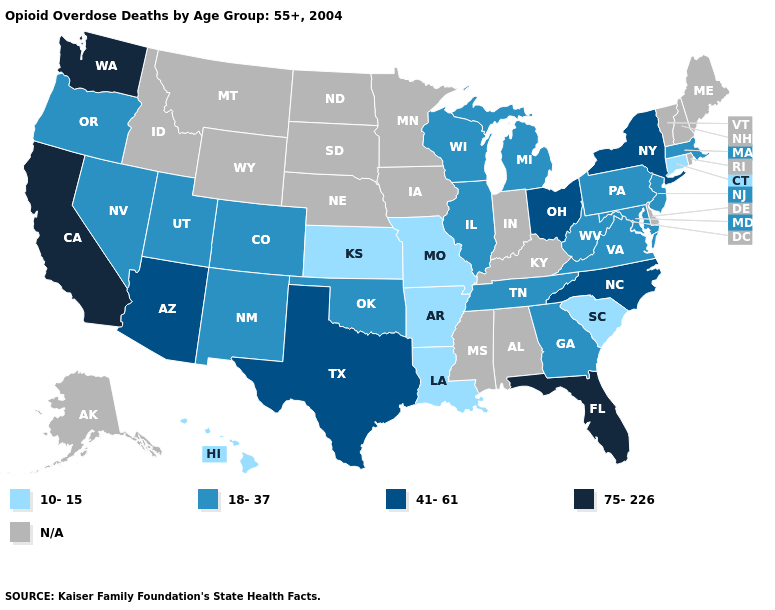What is the lowest value in the Northeast?
Keep it brief. 10-15. What is the value of New Mexico?
Answer briefly. 18-37. Name the states that have a value in the range 41-61?
Concise answer only. Arizona, New York, North Carolina, Ohio, Texas. Does New York have the highest value in the Northeast?
Give a very brief answer. Yes. Name the states that have a value in the range 10-15?
Give a very brief answer. Arkansas, Connecticut, Hawaii, Kansas, Louisiana, Missouri, South Carolina. How many symbols are there in the legend?
Concise answer only. 5. What is the value of South Carolina?
Quick response, please. 10-15. What is the highest value in the South ?
Short answer required. 75-226. Does Washington have the highest value in the USA?
Short answer required. Yes. Among the states that border Rhode Island , which have the highest value?
Be succinct. Massachusetts. What is the value of Louisiana?
Answer briefly. 10-15. Name the states that have a value in the range 75-226?
Short answer required. California, Florida, Washington. What is the value of Idaho?
Keep it brief. N/A. What is the highest value in the South ?
Short answer required. 75-226. 